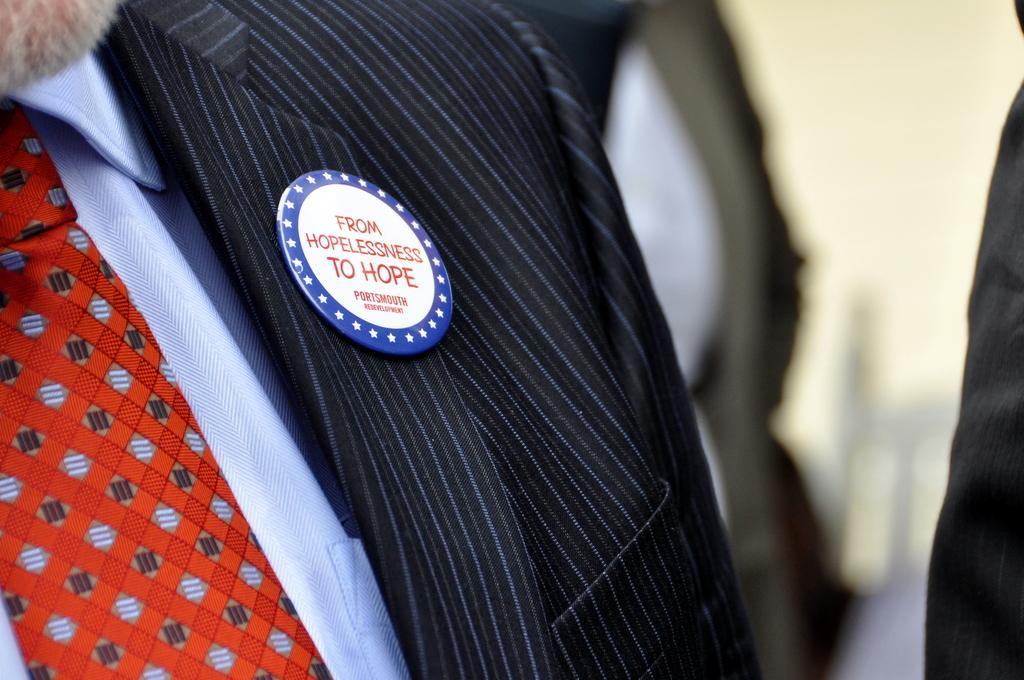How would you summarize this image in a sentence or two? There is a badge on a suit. A person is wearing it. The background is blurred. 